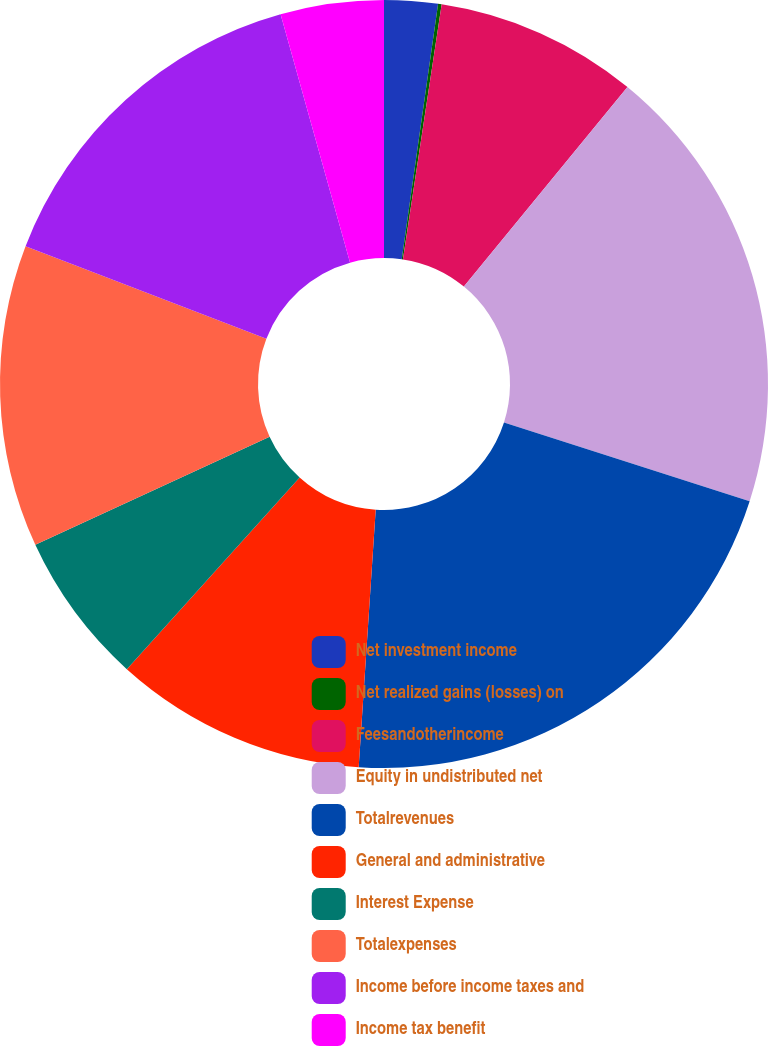<chart> <loc_0><loc_0><loc_500><loc_500><pie_chart><fcel>Net investment income<fcel>Net realized gains (losses) on<fcel>Feesandotherincome<fcel>Equity in undistributed net<fcel>Totalrevenues<fcel>General and administrative<fcel>Interest Expense<fcel>Totalexpenses<fcel>Income before income taxes and<fcel>Income tax benefit<nl><fcel>2.25%<fcel>0.15%<fcel>8.53%<fcel>19.01%<fcel>21.11%<fcel>10.63%<fcel>6.44%<fcel>12.72%<fcel>14.82%<fcel>4.34%<nl></chart> 